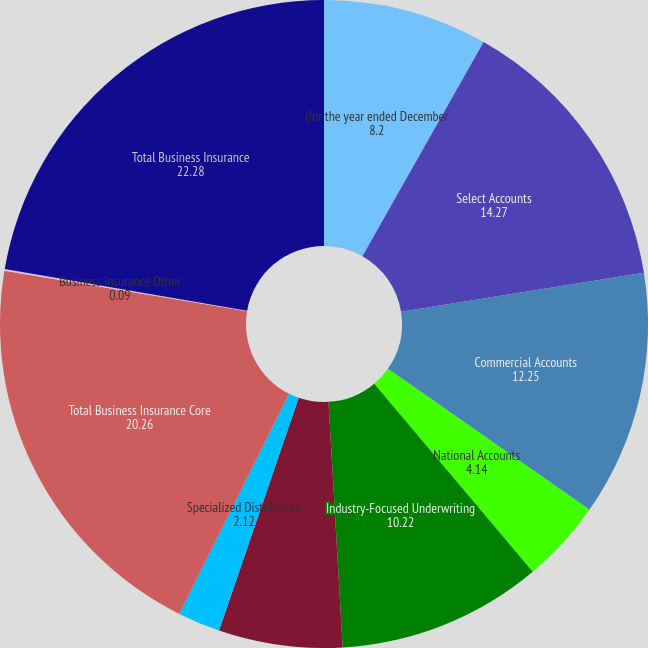Convert chart. <chart><loc_0><loc_0><loc_500><loc_500><pie_chart><fcel>(for the year ended December<fcel>Select Accounts<fcel>Commercial Accounts<fcel>National Accounts<fcel>Industry-Focused Underwriting<fcel>Target Risk Underwriting<fcel>Specialized Distribution<fcel>Total Business Insurance Core<fcel>Business Insurance Other<fcel>Total Business Insurance<nl><fcel>8.2%<fcel>14.27%<fcel>12.25%<fcel>4.14%<fcel>10.22%<fcel>6.17%<fcel>2.12%<fcel>20.26%<fcel>0.09%<fcel>22.28%<nl></chart> 